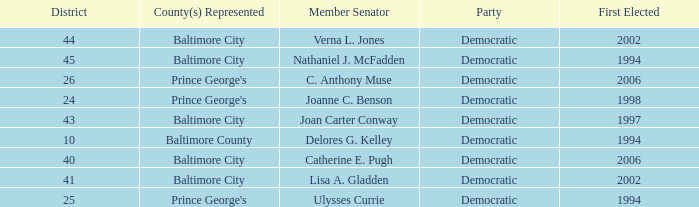What district for ulysses currie? 25.0. 